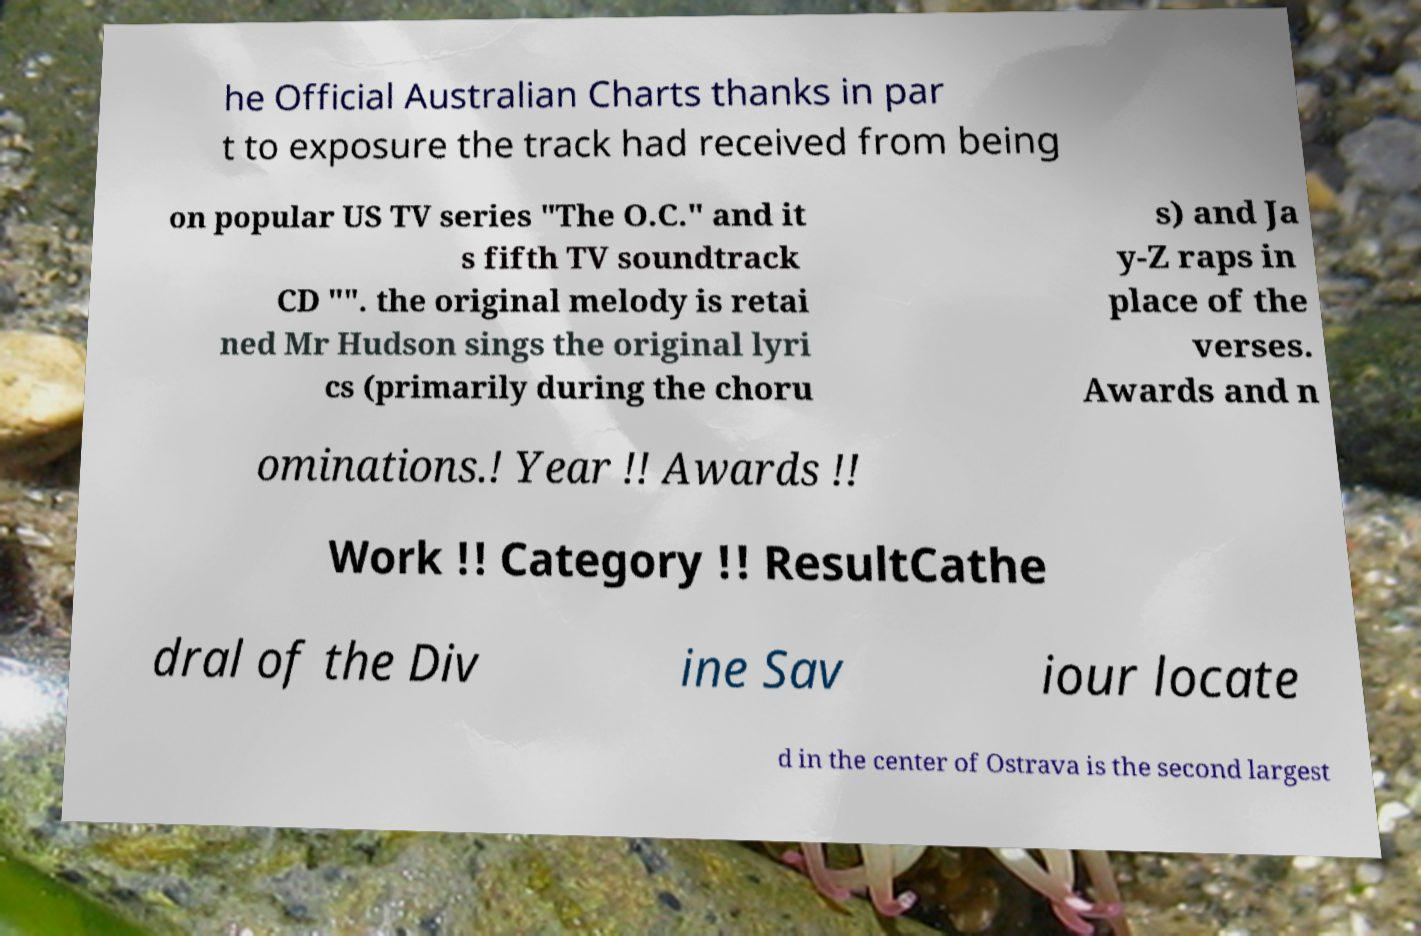Could you assist in decoding the text presented in this image and type it out clearly? he Official Australian Charts thanks in par t to exposure the track had received from being on popular US TV series "The O.C." and it s fifth TV soundtrack CD "". the original melody is retai ned Mr Hudson sings the original lyri cs (primarily during the choru s) and Ja y-Z raps in place of the verses. Awards and n ominations.! Year !! Awards !! Work !! Category !! ResultCathe dral of the Div ine Sav iour locate d in the center of Ostrava is the second largest 